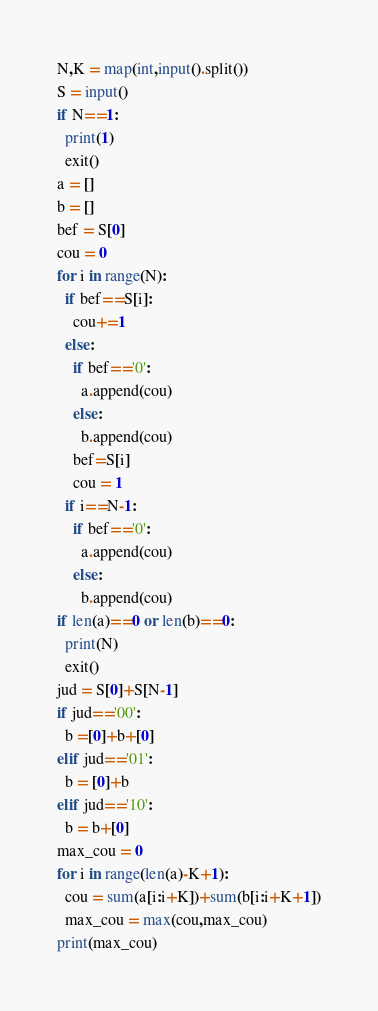Convert code to text. <code><loc_0><loc_0><loc_500><loc_500><_Python_>N,K = map(int,input().split())
S = input()
if N==1:
  print(1)
  exit()
a = []
b = []
bef = S[0]
cou = 0
for i in range(N):
  if bef==S[i]:
    cou+=1
  else:
    if bef=='0':
      a.append(cou)
    else:
      b.append(cou)
    bef=S[i]
    cou = 1
  if i==N-1:
    if bef=='0':
      a.append(cou)
    else:
      b.append(cou)
if len(a)==0 or len(b)==0:
  print(N)
  exit()
jud = S[0]+S[N-1]
if jud=='00':
  b =[0]+b+[0]
elif jud=='01':
  b = [0]+b
elif jud=='10':
  b = b+[0]
max_cou = 0
for i in range(len(a)-K+1):
  cou = sum(a[i:i+K])+sum(b[i:i+K+1])
  max_cou = max(cou,max_cou)
print(max_cou)</code> 